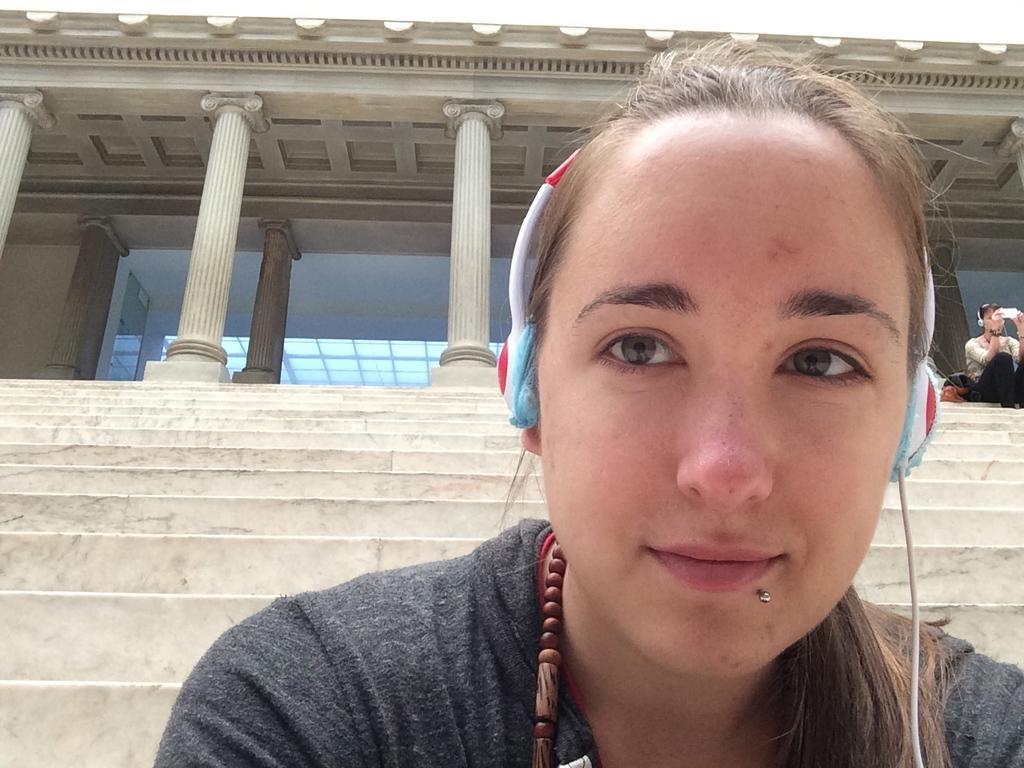Could you give a brief overview of what you see in this image? In the foreground of the picture there is a woman wearing headphones. On the right there is a person sitting on the staircase. At the top there is a building. 